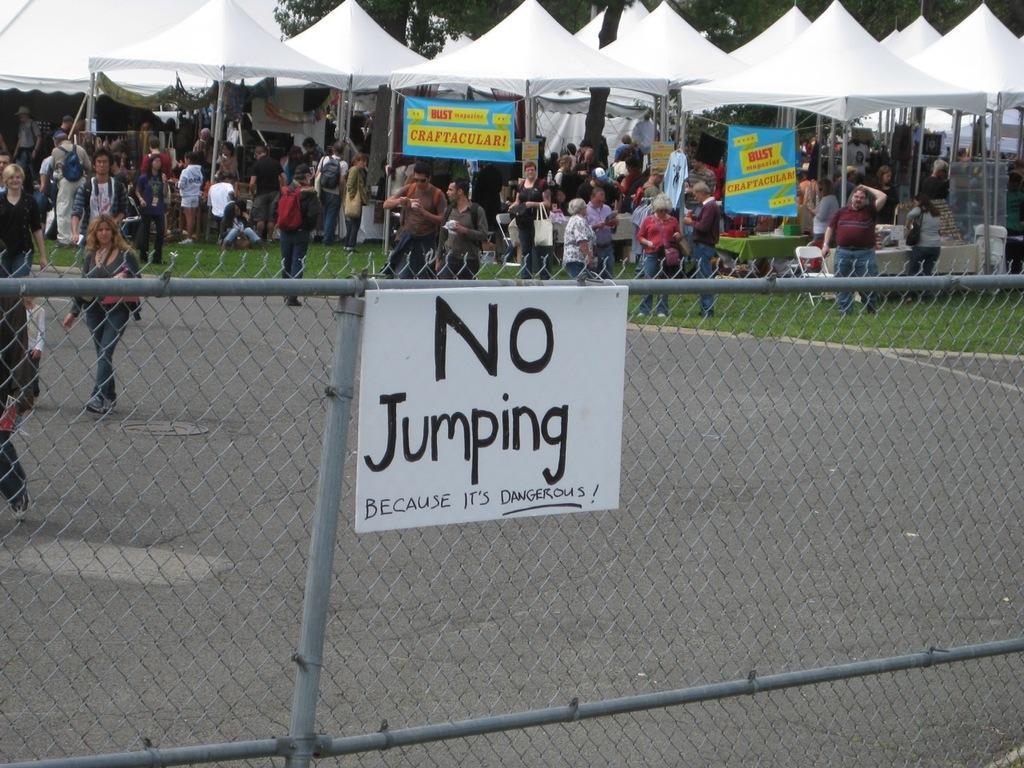Could you give a brief overview of what you see in this image? This is an outside view. In the foreground there is a net to which a white color board is attached. On the board, I can see some text. At the back of this net there is a road. I can see people walking on this road. In the background there are many people standing under the tents. At the top there are some trees. 